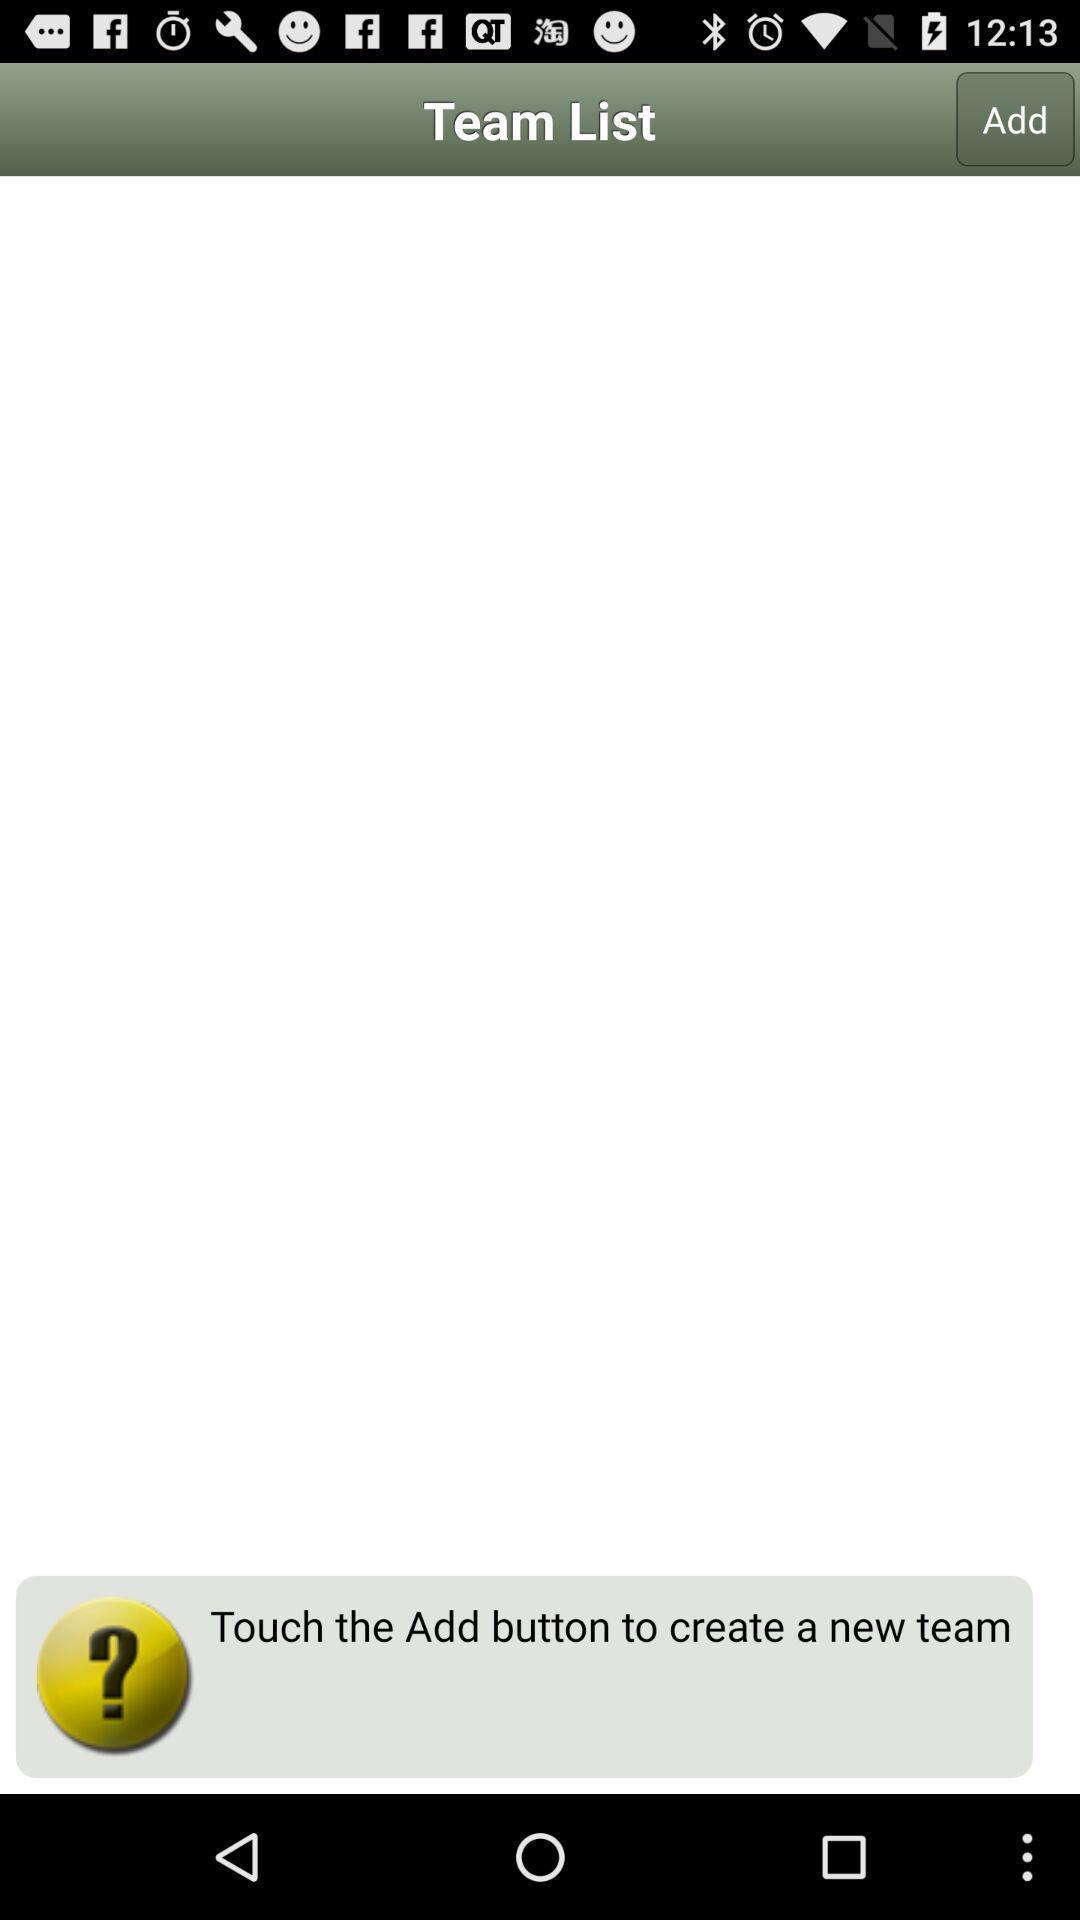Provide a detailed account of this screenshot. Page displaying to create a new team. 